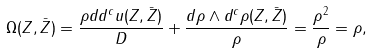Convert formula to latex. <formula><loc_0><loc_0><loc_500><loc_500>\Omega ( Z , \bar { Z } ) = \frac { \rho d d ^ { c } u ( Z , \bar { Z } ) } { D } + \frac { d \rho \wedge d ^ { c } \rho ( Z , \bar { Z } ) } { \rho } = \frac { \rho ^ { 2 } } { \rho } = \rho ,</formula> 